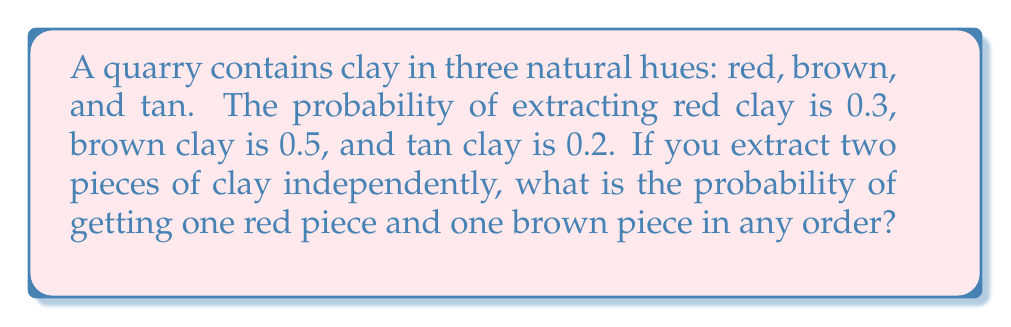Solve this math problem. Let's approach this step-by-step:

1) We need to consider two scenarios:
   a) Red clay first, then brown clay
   b) Brown clay first, then red clay

2) For scenario a:
   - Probability of red clay on first extraction: $P(R) = 0.3$
   - Probability of brown clay on second extraction: $P(B) = 0.5$
   - Probability of this scenario: $P(R) \times P(B) = 0.3 \times 0.5 = 0.15$

3) For scenario b:
   - Probability of brown clay on first extraction: $P(B) = 0.5$
   - Probability of red clay on second extraction: $P(R) = 0.3$
   - Probability of this scenario: $P(B) \times P(R) = 0.5 \times 0.3 = 0.15$

4) The total probability is the sum of probabilities of both scenarios:
   $P(\text{one red and one brown}) = P(\text{scenario a}) + P(\text{scenario b})$
   $= 0.15 + 0.15 = 0.30$

Therefore, the probability of extracting one red piece and one brown piece in any order is 0.30 or 30%.
Answer: 0.30 